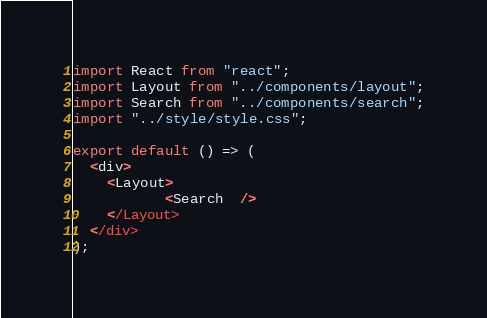Convert code to text. <code><loc_0><loc_0><loc_500><loc_500><_JavaScript_>import React from "react";
import Layout from "../components/layout";
import Search from "../components/search";
import "../style/style.css";

export default () => (
  <div>
    <Layout>
           <Search  />
    </Layout>
  </div>
);
</code> 